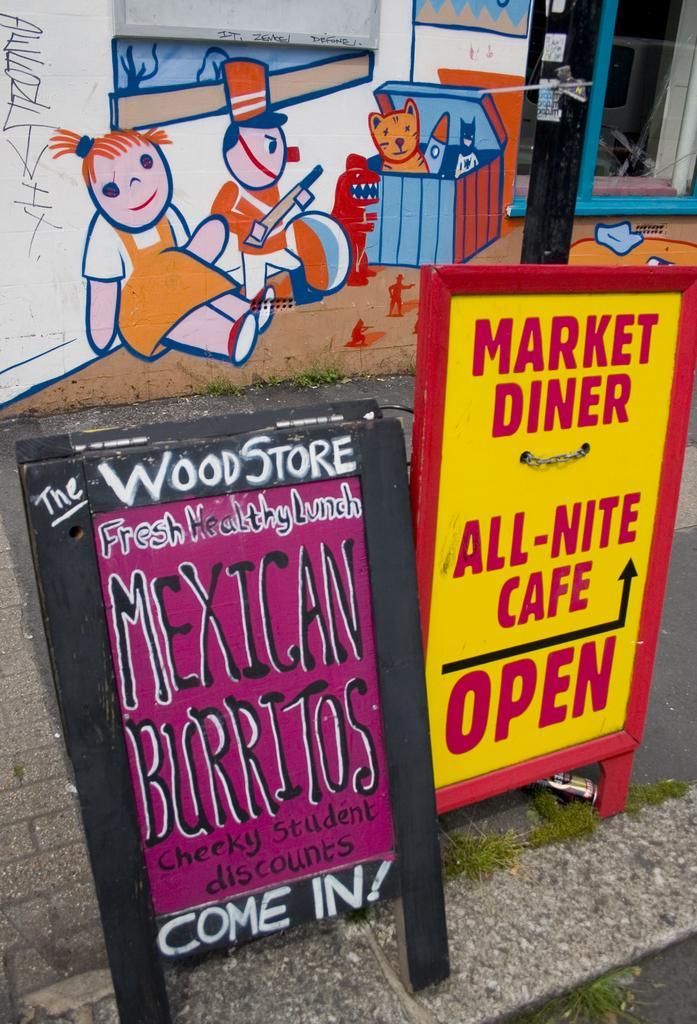Please provide a concise description of this image. In the image in the center we can see two banners. On one of the banner,it is written as "Market Diner". In the background there is a wall,grass,glass door,pole and few other objects. And we can see,some painting on the wall. 